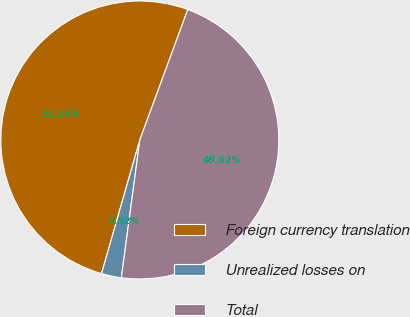<chart> <loc_0><loc_0><loc_500><loc_500><pie_chart><fcel>Foreign currency translation<fcel>Unrealized losses on<fcel>Total<nl><fcel>51.17%<fcel>2.32%<fcel>46.52%<nl></chart> 